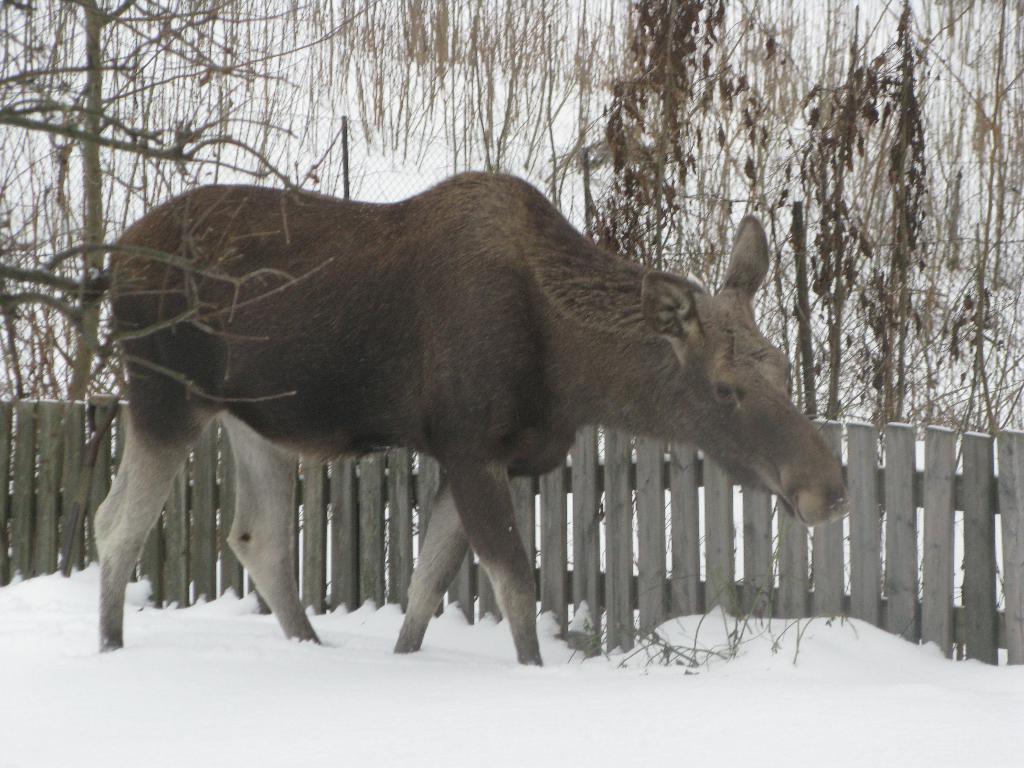Can you describe this image briefly? As we can see in the image there is an animal, snow, fence and trees. 